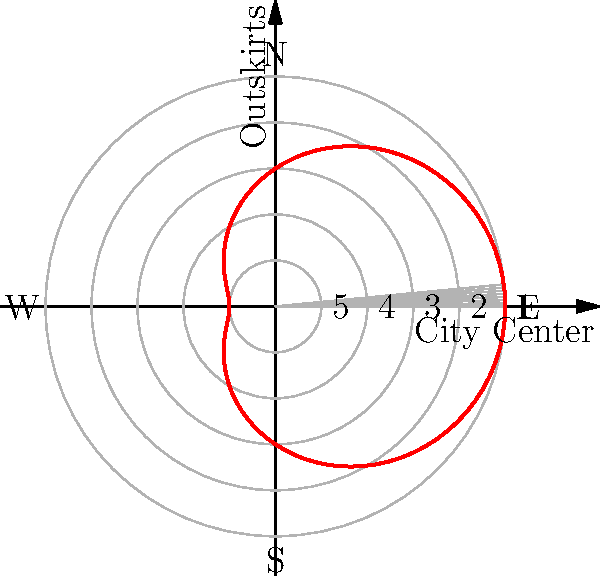In the polar coordinate representation of street art distribution in a city, the distance from the center represents the density of street art (5 being highest, 1 being lowest). The red curve shows the actual distribution. Which cardinal direction from the city center has the highest concentration of street art, and what might be a historical or cultural reason for this pattern? To answer this question, we need to analyze the polar graph and its implications:

1. The polar graph represents the distribution of street art from the city center (origin) to the outskirts.
2. The concentric circles represent the density of street art, with 5 being the highest and 1 being the lowest.
3. The red curve shows the actual distribution of street art across different directions.
4. To find the direction with the highest concentration, we need to locate where the red curve extends furthest from the center.

Analyzing the graph:
1. The curve extends furthest to the right, which corresponds to the East direction.
2. The maximum extension appears to be between 4 and 5 on the density scale.

Historical or cultural reasons for this pattern could include:
1. East side of cities often developed as industrial or working-class areas, which are typically more amenable to street art culture.
2. Historical migration patterns might have led to a concentration of artistic communities in the eastern part of the city.
3. Urban renewal projects in the eastern areas might have provided more blank walls or spaces for street artists.
4. Cultural institutions or art districts might have developed in the eastern part of the city, attracting more artists to that area.

The specific reason would depend on the particular city in question, but these are common factors that influence street art distribution.
Answer: East; likely due to historical development patterns or cultural clustering 